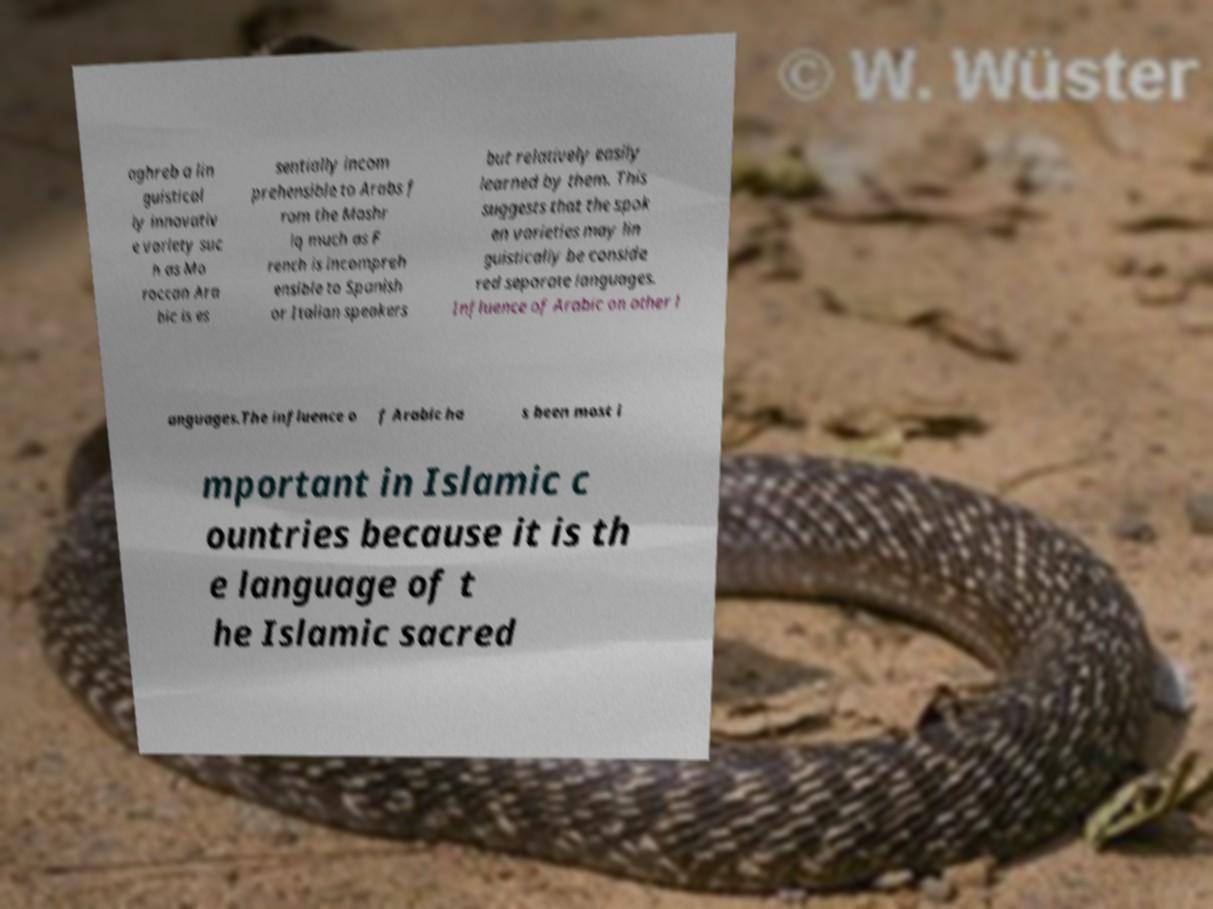Please read and relay the text visible in this image. What does it say? aghreb a lin guistical ly innovativ e variety suc h as Mo roccan Ara bic is es sentially incom prehensible to Arabs f rom the Mashr iq much as F rench is incompreh ensible to Spanish or Italian speakers but relatively easily learned by them. This suggests that the spok en varieties may lin guistically be conside red separate languages. Influence of Arabic on other l anguages.The influence o f Arabic ha s been most i mportant in Islamic c ountries because it is th e language of t he Islamic sacred 